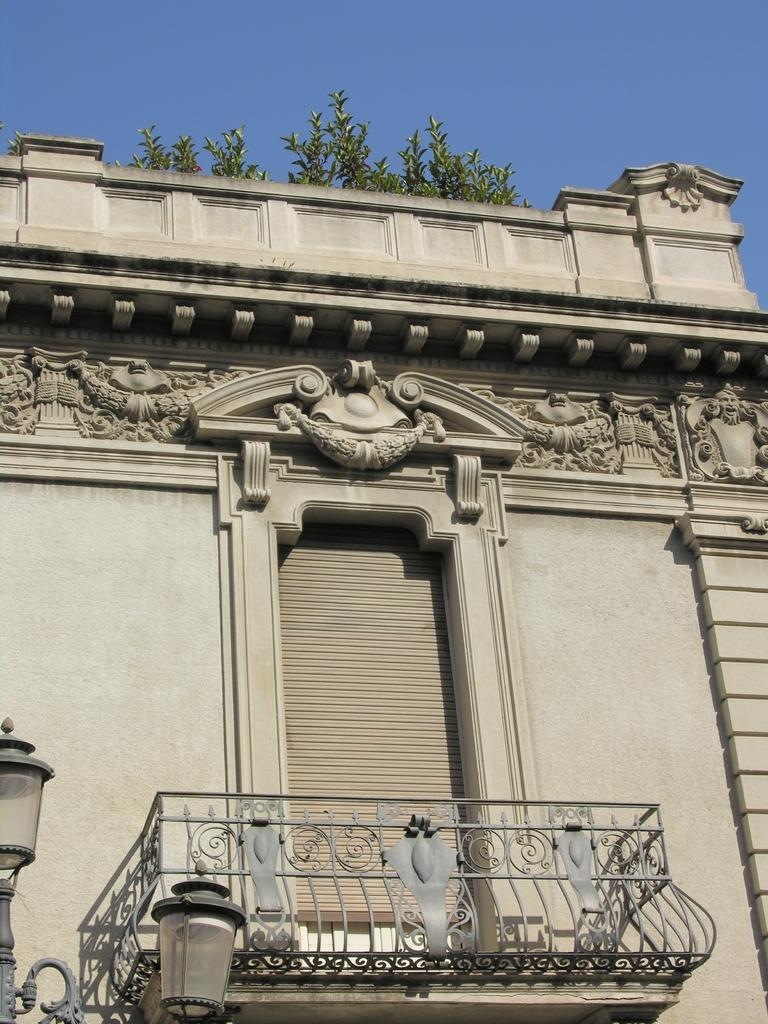What type of structure is visible in the picture? There is a building in the picture. Where are the lights located in the picture? Two lights are present at the left bottom of the picture. What feature is present at the bottom of the picture? There is a balcony at the bottom of the picture. What type of vegetation can be seen in the picture? There are plants in the picture. What is visible at the top of the picture? The sky is visible at the top of the picture. What type of stick can be seen in the picture? There is no stick present in the picture. What type of juice is being served on the balcony in the picture? There is no juice or any indication of food or drink in the picture. 